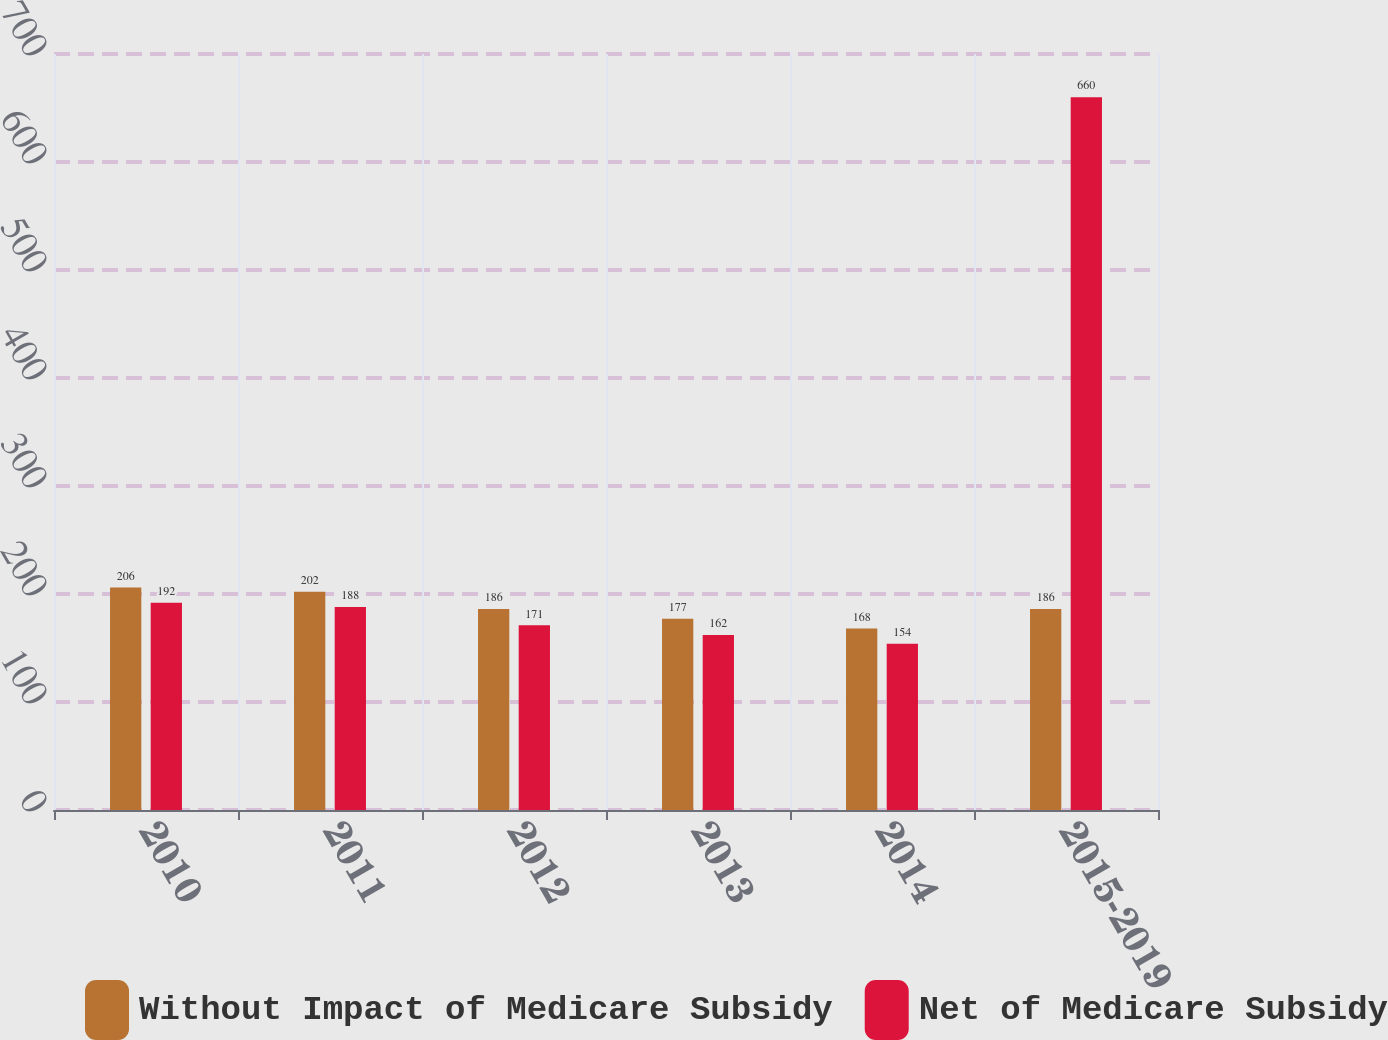Convert chart to OTSL. <chart><loc_0><loc_0><loc_500><loc_500><stacked_bar_chart><ecel><fcel>2010<fcel>2011<fcel>2012<fcel>2013<fcel>2014<fcel>2015-2019<nl><fcel>Without Impact of Medicare Subsidy<fcel>206<fcel>202<fcel>186<fcel>177<fcel>168<fcel>186<nl><fcel>Net of Medicare Subsidy<fcel>192<fcel>188<fcel>171<fcel>162<fcel>154<fcel>660<nl></chart> 